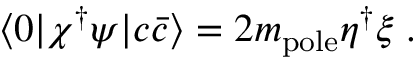Convert formula to latex. <formula><loc_0><loc_0><loc_500><loc_500>\langle 0 | \chi ^ { \dagger } \psi | c \bar { c } \rangle = 2 m _ { p o l e } \eta ^ { \dagger } \xi \, .</formula> 